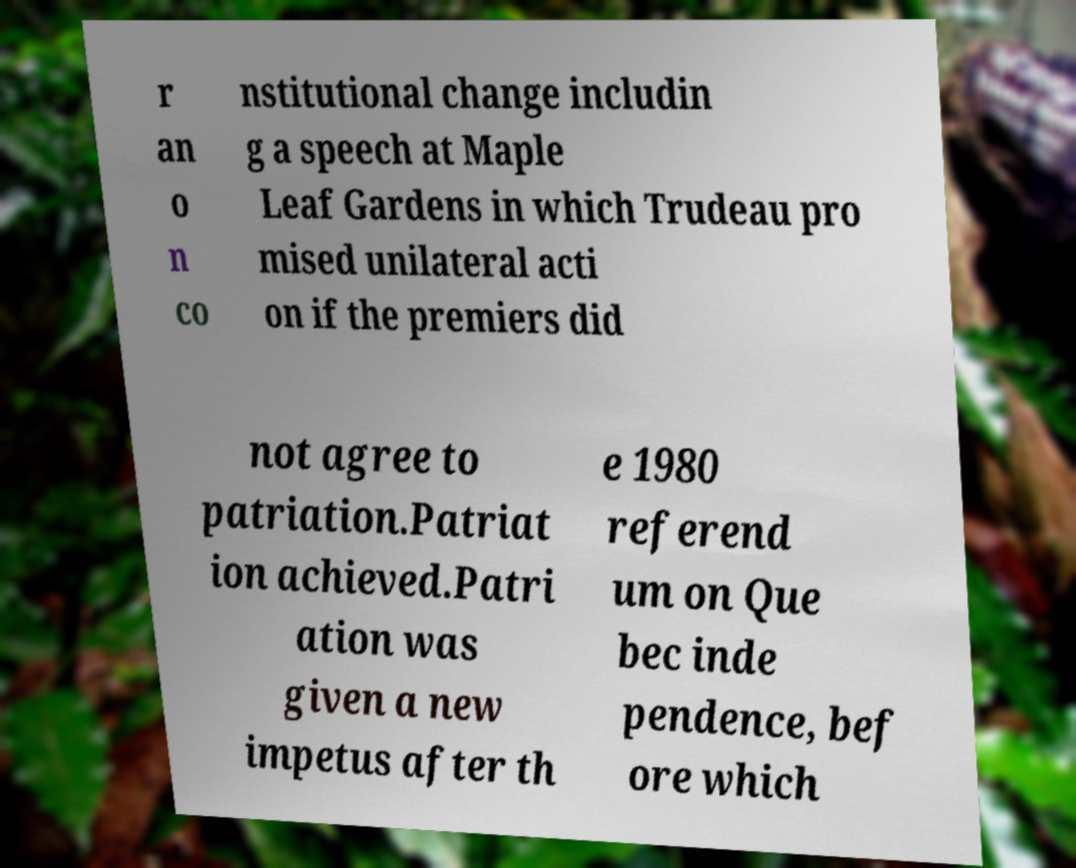For documentation purposes, I need the text within this image transcribed. Could you provide that? r an o n co nstitutional change includin g a speech at Maple Leaf Gardens in which Trudeau pro mised unilateral acti on if the premiers did not agree to patriation.Patriat ion achieved.Patri ation was given a new impetus after th e 1980 referend um on Que bec inde pendence, bef ore which 